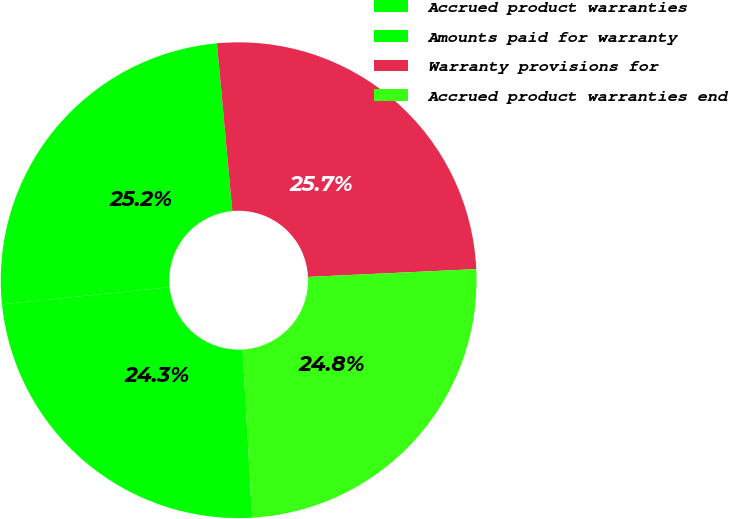Convert chart. <chart><loc_0><loc_0><loc_500><loc_500><pie_chart><fcel>Accrued product warranties<fcel>Amounts paid for warranty<fcel>Warranty provisions for<fcel>Accrued product warranties end<nl><fcel>24.29%<fcel>25.16%<fcel>25.71%<fcel>24.84%<nl></chart> 